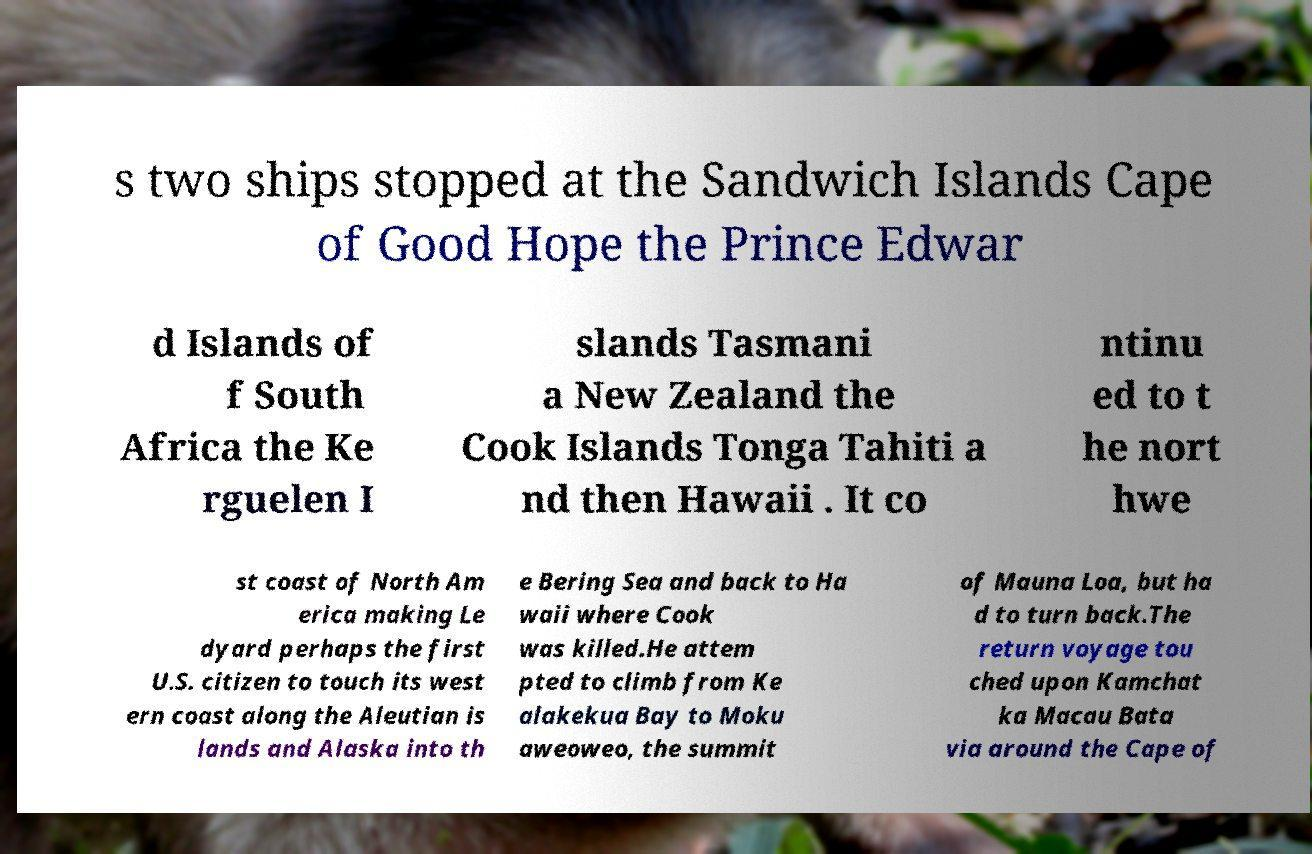Please identify and transcribe the text found in this image. s two ships stopped at the Sandwich Islands Cape of Good Hope the Prince Edwar d Islands of f South Africa the Ke rguelen I slands Tasmani a New Zealand the Cook Islands Tonga Tahiti a nd then Hawaii . It co ntinu ed to t he nort hwe st coast of North Am erica making Le dyard perhaps the first U.S. citizen to touch its west ern coast along the Aleutian is lands and Alaska into th e Bering Sea and back to Ha waii where Cook was killed.He attem pted to climb from Ke alakekua Bay to Moku aweoweo, the summit of Mauna Loa, but ha d to turn back.The return voyage tou ched upon Kamchat ka Macau Bata via around the Cape of 